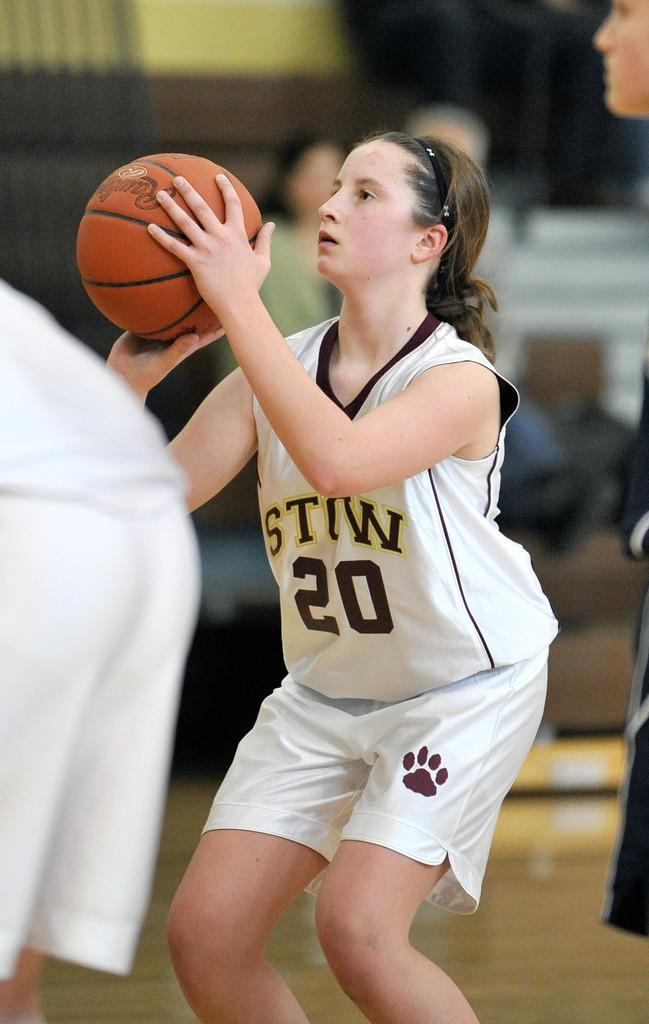<image>
Give a short and clear explanation of the subsequent image. Player number 20 shoots a free throw during a basketball game. 